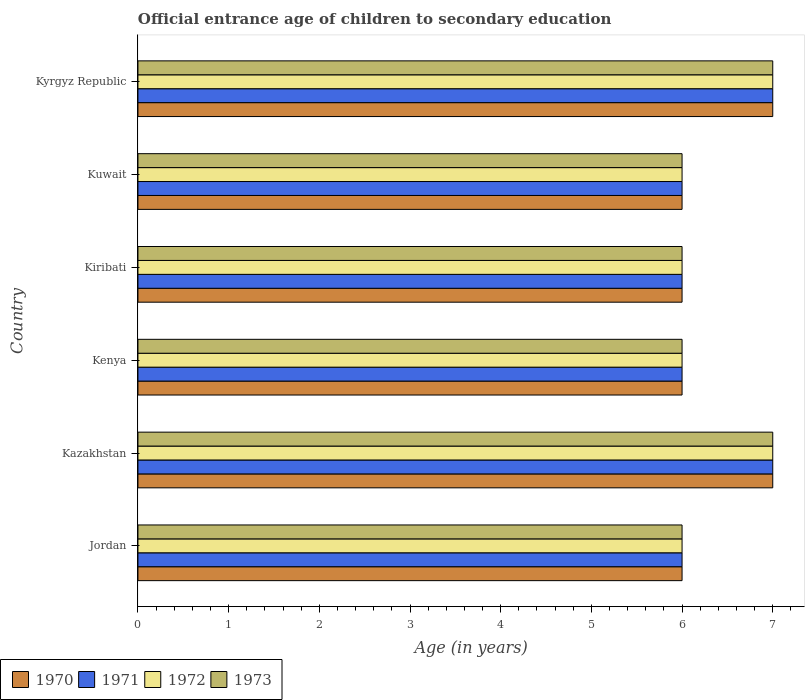How many different coloured bars are there?
Ensure brevity in your answer.  4. How many groups of bars are there?
Make the answer very short. 6. What is the label of the 5th group of bars from the top?
Make the answer very short. Kazakhstan. What is the secondary school starting age of children in 1972 in Kyrgyz Republic?
Keep it short and to the point. 7. Across all countries, what is the maximum secondary school starting age of children in 1970?
Your response must be concise. 7. Across all countries, what is the minimum secondary school starting age of children in 1970?
Provide a succinct answer. 6. In which country was the secondary school starting age of children in 1972 maximum?
Give a very brief answer. Kazakhstan. In which country was the secondary school starting age of children in 1972 minimum?
Keep it short and to the point. Jordan. What is the difference between the secondary school starting age of children in 1971 in Kazakhstan and the secondary school starting age of children in 1973 in Kuwait?
Your response must be concise. 1. What is the average secondary school starting age of children in 1970 per country?
Your response must be concise. 6.33. Is the secondary school starting age of children in 1971 in Kazakhstan less than that in Kuwait?
Offer a terse response. No. What is the difference between the highest and the second highest secondary school starting age of children in 1973?
Offer a very short reply. 0. What is the difference between the highest and the lowest secondary school starting age of children in 1973?
Your answer should be compact. 1. Is the sum of the secondary school starting age of children in 1972 in Kazakhstan and Kyrgyz Republic greater than the maximum secondary school starting age of children in 1970 across all countries?
Give a very brief answer. Yes. What does the 2nd bar from the bottom in Kuwait represents?
Make the answer very short. 1971. How many bars are there?
Provide a succinct answer. 24. What is the difference between two consecutive major ticks on the X-axis?
Your answer should be compact. 1. Are the values on the major ticks of X-axis written in scientific E-notation?
Offer a terse response. No. Does the graph contain any zero values?
Make the answer very short. No. Does the graph contain grids?
Ensure brevity in your answer.  No. Where does the legend appear in the graph?
Ensure brevity in your answer.  Bottom left. How many legend labels are there?
Give a very brief answer. 4. How are the legend labels stacked?
Your response must be concise. Horizontal. What is the title of the graph?
Offer a very short reply. Official entrance age of children to secondary education. What is the label or title of the X-axis?
Your answer should be very brief. Age (in years). What is the Age (in years) of 1972 in Jordan?
Provide a short and direct response. 6. What is the Age (in years) in 1970 in Kazakhstan?
Your response must be concise. 7. What is the Age (in years) in 1972 in Kazakhstan?
Keep it short and to the point. 7. What is the Age (in years) in 1973 in Kazakhstan?
Give a very brief answer. 7. What is the Age (in years) of 1970 in Kenya?
Offer a terse response. 6. What is the Age (in years) of 1973 in Kenya?
Provide a short and direct response. 6. What is the Age (in years) in 1970 in Kiribati?
Ensure brevity in your answer.  6. What is the Age (in years) in 1973 in Kiribati?
Provide a short and direct response. 6. What is the Age (in years) of 1972 in Kuwait?
Your answer should be compact. 6. What is the Age (in years) in 1973 in Kuwait?
Ensure brevity in your answer.  6. What is the Age (in years) of 1973 in Kyrgyz Republic?
Provide a succinct answer. 7. Across all countries, what is the maximum Age (in years) in 1970?
Your answer should be compact. 7. Across all countries, what is the maximum Age (in years) in 1971?
Make the answer very short. 7. Across all countries, what is the minimum Age (in years) in 1970?
Give a very brief answer. 6. Across all countries, what is the minimum Age (in years) of 1971?
Keep it short and to the point. 6. Across all countries, what is the minimum Age (in years) in 1973?
Keep it short and to the point. 6. What is the difference between the Age (in years) in 1972 in Jordan and that in Kazakhstan?
Provide a short and direct response. -1. What is the difference between the Age (in years) in 1973 in Jordan and that in Kazakhstan?
Keep it short and to the point. -1. What is the difference between the Age (in years) in 1970 in Jordan and that in Kenya?
Keep it short and to the point. 0. What is the difference between the Age (in years) in 1972 in Jordan and that in Kenya?
Offer a very short reply. 0. What is the difference between the Age (in years) in 1973 in Jordan and that in Kenya?
Offer a very short reply. 0. What is the difference between the Age (in years) in 1970 in Jordan and that in Kiribati?
Offer a very short reply. 0. What is the difference between the Age (in years) in 1971 in Jordan and that in Kiribati?
Your answer should be very brief. 0. What is the difference between the Age (in years) of 1973 in Jordan and that in Kiribati?
Offer a terse response. 0. What is the difference between the Age (in years) of 1970 in Jordan and that in Kuwait?
Keep it short and to the point. 0. What is the difference between the Age (in years) of 1971 in Jordan and that in Kyrgyz Republic?
Provide a short and direct response. -1. What is the difference between the Age (in years) in 1972 in Jordan and that in Kyrgyz Republic?
Provide a short and direct response. -1. What is the difference between the Age (in years) of 1973 in Jordan and that in Kyrgyz Republic?
Offer a very short reply. -1. What is the difference between the Age (in years) of 1971 in Kazakhstan and that in Kenya?
Ensure brevity in your answer.  1. What is the difference between the Age (in years) of 1972 in Kazakhstan and that in Kenya?
Your response must be concise. 1. What is the difference between the Age (in years) of 1971 in Kazakhstan and that in Kiribati?
Ensure brevity in your answer.  1. What is the difference between the Age (in years) of 1970 in Kazakhstan and that in Kuwait?
Ensure brevity in your answer.  1. What is the difference between the Age (in years) in 1971 in Kazakhstan and that in Kuwait?
Provide a short and direct response. 1. What is the difference between the Age (in years) in 1972 in Kazakhstan and that in Kyrgyz Republic?
Your response must be concise. 0. What is the difference between the Age (in years) in 1973 in Kazakhstan and that in Kyrgyz Republic?
Provide a short and direct response. 0. What is the difference between the Age (in years) of 1970 in Kenya and that in Kiribati?
Make the answer very short. 0. What is the difference between the Age (in years) in 1971 in Kenya and that in Kiribati?
Provide a succinct answer. 0. What is the difference between the Age (in years) of 1973 in Kenya and that in Kyrgyz Republic?
Provide a succinct answer. -1. What is the difference between the Age (in years) in 1970 in Kiribati and that in Kuwait?
Your answer should be compact. 0. What is the difference between the Age (in years) in 1970 in Kiribati and that in Kyrgyz Republic?
Make the answer very short. -1. What is the difference between the Age (in years) of 1971 in Kiribati and that in Kyrgyz Republic?
Make the answer very short. -1. What is the difference between the Age (in years) of 1972 in Kiribati and that in Kyrgyz Republic?
Offer a very short reply. -1. What is the difference between the Age (in years) in 1970 in Kuwait and that in Kyrgyz Republic?
Keep it short and to the point. -1. What is the difference between the Age (in years) of 1971 in Kuwait and that in Kyrgyz Republic?
Ensure brevity in your answer.  -1. What is the difference between the Age (in years) in 1970 in Jordan and the Age (in years) in 1972 in Kazakhstan?
Your answer should be very brief. -1. What is the difference between the Age (in years) in 1971 in Jordan and the Age (in years) in 1973 in Kazakhstan?
Offer a very short reply. -1. What is the difference between the Age (in years) of 1970 in Jordan and the Age (in years) of 1973 in Kenya?
Ensure brevity in your answer.  0. What is the difference between the Age (in years) in 1971 in Jordan and the Age (in years) in 1972 in Kiribati?
Give a very brief answer. 0. What is the difference between the Age (in years) in 1971 in Jordan and the Age (in years) in 1973 in Kiribati?
Offer a very short reply. 0. What is the difference between the Age (in years) of 1972 in Jordan and the Age (in years) of 1973 in Kiribati?
Keep it short and to the point. 0. What is the difference between the Age (in years) of 1970 in Jordan and the Age (in years) of 1971 in Kuwait?
Make the answer very short. 0. What is the difference between the Age (in years) of 1970 in Jordan and the Age (in years) of 1973 in Kuwait?
Your answer should be very brief. 0. What is the difference between the Age (in years) of 1971 in Jordan and the Age (in years) of 1972 in Kuwait?
Give a very brief answer. 0. What is the difference between the Age (in years) in 1970 in Jordan and the Age (in years) in 1972 in Kyrgyz Republic?
Keep it short and to the point. -1. What is the difference between the Age (in years) of 1971 in Jordan and the Age (in years) of 1972 in Kyrgyz Republic?
Your response must be concise. -1. What is the difference between the Age (in years) in 1971 in Jordan and the Age (in years) in 1973 in Kyrgyz Republic?
Your answer should be compact. -1. What is the difference between the Age (in years) in 1970 in Kazakhstan and the Age (in years) in 1971 in Kenya?
Offer a very short reply. 1. What is the difference between the Age (in years) in 1970 in Kazakhstan and the Age (in years) in 1972 in Kenya?
Offer a terse response. 1. What is the difference between the Age (in years) in 1971 in Kazakhstan and the Age (in years) in 1972 in Kenya?
Ensure brevity in your answer.  1. What is the difference between the Age (in years) of 1972 in Kazakhstan and the Age (in years) of 1973 in Kenya?
Offer a terse response. 1. What is the difference between the Age (in years) of 1970 in Kazakhstan and the Age (in years) of 1973 in Kiribati?
Your answer should be compact. 1. What is the difference between the Age (in years) in 1971 in Kazakhstan and the Age (in years) in 1973 in Kiribati?
Your answer should be very brief. 1. What is the difference between the Age (in years) of 1972 in Kazakhstan and the Age (in years) of 1973 in Kiribati?
Your answer should be very brief. 1. What is the difference between the Age (in years) of 1971 in Kazakhstan and the Age (in years) of 1972 in Kuwait?
Provide a short and direct response. 1. What is the difference between the Age (in years) of 1971 in Kazakhstan and the Age (in years) of 1973 in Kuwait?
Your response must be concise. 1. What is the difference between the Age (in years) of 1970 in Kazakhstan and the Age (in years) of 1972 in Kyrgyz Republic?
Make the answer very short. 0. What is the difference between the Age (in years) in 1970 in Kazakhstan and the Age (in years) in 1973 in Kyrgyz Republic?
Provide a succinct answer. 0. What is the difference between the Age (in years) of 1971 in Kazakhstan and the Age (in years) of 1973 in Kyrgyz Republic?
Ensure brevity in your answer.  0. What is the difference between the Age (in years) in 1970 in Kenya and the Age (in years) in 1971 in Kiribati?
Your response must be concise. 0. What is the difference between the Age (in years) in 1970 in Kenya and the Age (in years) in 1973 in Kiribati?
Your answer should be very brief. 0. What is the difference between the Age (in years) in 1972 in Kenya and the Age (in years) in 1973 in Kiribati?
Provide a succinct answer. 0. What is the difference between the Age (in years) of 1970 in Kenya and the Age (in years) of 1971 in Kuwait?
Provide a succinct answer. 0. What is the difference between the Age (in years) in 1970 in Kenya and the Age (in years) in 1973 in Kuwait?
Ensure brevity in your answer.  0. What is the difference between the Age (in years) of 1971 in Kenya and the Age (in years) of 1973 in Kuwait?
Provide a succinct answer. 0. What is the difference between the Age (in years) in 1970 in Kenya and the Age (in years) in 1972 in Kyrgyz Republic?
Offer a very short reply. -1. What is the difference between the Age (in years) in 1970 in Kenya and the Age (in years) in 1973 in Kyrgyz Republic?
Your answer should be very brief. -1. What is the difference between the Age (in years) in 1971 in Kenya and the Age (in years) in 1972 in Kyrgyz Republic?
Offer a terse response. -1. What is the difference between the Age (in years) in 1972 in Kenya and the Age (in years) in 1973 in Kyrgyz Republic?
Your answer should be very brief. -1. What is the difference between the Age (in years) in 1970 in Kiribati and the Age (in years) in 1971 in Kuwait?
Offer a terse response. 0. What is the difference between the Age (in years) of 1970 in Kiribati and the Age (in years) of 1972 in Kuwait?
Offer a terse response. 0. What is the difference between the Age (in years) in 1970 in Kiribati and the Age (in years) in 1973 in Kuwait?
Offer a very short reply. 0. What is the difference between the Age (in years) of 1971 in Kiribati and the Age (in years) of 1972 in Kuwait?
Provide a short and direct response. 0. What is the difference between the Age (in years) in 1971 in Kiribati and the Age (in years) in 1973 in Kuwait?
Provide a short and direct response. 0. What is the difference between the Age (in years) of 1970 in Kiribati and the Age (in years) of 1971 in Kyrgyz Republic?
Provide a short and direct response. -1. What is the difference between the Age (in years) of 1971 in Kiribati and the Age (in years) of 1972 in Kyrgyz Republic?
Provide a succinct answer. -1. What is the difference between the Age (in years) of 1971 in Kiribati and the Age (in years) of 1973 in Kyrgyz Republic?
Offer a terse response. -1. What is the difference between the Age (in years) in 1970 in Kuwait and the Age (in years) in 1971 in Kyrgyz Republic?
Provide a succinct answer. -1. What is the difference between the Age (in years) in 1970 in Kuwait and the Age (in years) in 1972 in Kyrgyz Republic?
Your response must be concise. -1. What is the difference between the Age (in years) of 1970 in Kuwait and the Age (in years) of 1973 in Kyrgyz Republic?
Your answer should be very brief. -1. What is the average Age (in years) of 1970 per country?
Provide a short and direct response. 6.33. What is the average Age (in years) of 1971 per country?
Keep it short and to the point. 6.33. What is the average Age (in years) of 1972 per country?
Offer a very short reply. 6.33. What is the average Age (in years) in 1973 per country?
Ensure brevity in your answer.  6.33. What is the difference between the Age (in years) in 1970 and Age (in years) in 1971 in Jordan?
Your response must be concise. 0. What is the difference between the Age (in years) of 1970 and Age (in years) of 1972 in Jordan?
Offer a terse response. 0. What is the difference between the Age (in years) in 1971 and Age (in years) in 1972 in Jordan?
Provide a short and direct response. 0. What is the difference between the Age (in years) of 1971 and Age (in years) of 1973 in Jordan?
Ensure brevity in your answer.  0. What is the difference between the Age (in years) in 1972 and Age (in years) in 1973 in Jordan?
Ensure brevity in your answer.  0. What is the difference between the Age (in years) of 1970 and Age (in years) of 1971 in Kazakhstan?
Provide a short and direct response. 0. What is the difference between the Age (in years) of 1971 and Age (in years) of 1972 in Kenya?
Keep it short and to the point. 0. What is the difference between the Age (in years) of 1972 and Age (in years) of 1973 in Kenya?
Provide a succinct answer. 0. What is the difference between the Age (in years) in 1970 and Age (in years) in 1972 in Kiribati?
Provide a short and direct response. 0. What is the difference between the Age (in years) of 1971 and Age (in years) of 1973 in Kiribati?
Provide a succinct answer. 0. What is the difference between the Age (in years) of 1970 and Age (in years) of 1972 in Kuwait?
Offer a terse response. 0. What is the difference between the Age (in years) of 1970 and Age (in years) of 1973 in Kuwait?
Make the answer very short. 0. What is the difference between the Age (in years) in 1971 and Age (in years) in 1973 in Kuwait?
Provide a succinct answer. 0. What is the difference between the Age (in years) of 1970 and Age (in years) of 1972 in Kyrgyz Republic?
Offer a terse response. 0. What is the ratio of the Age (in years) of 1970 in Jordan to that in Kazakhstan?
Offer a terse response. 0.86. What is the ratio of the Age (in years) in 1971 in Jordan to that in Kazakhstan?
Offer a terse response. 0.86. What is the ratio of the Age (in years) in 1970 in Jordan to that in Kenya?
Your answer should be very brief. 1. What is the ratio of the Age (in years) in 1971 in Jordan to that in Kenya?
Provide a succinct answer. 1. What is the ratio of the Age (in years) of 1972 in Jordan to that in Kenya?
Provide a short and direct response. 1. What is the ratio of the Age (in years) in 1970 in Jordan to that in Kiribati?
Make the answer very short. 1. What is the ratio of the Age (in years) of 1971 in Jordan to that in Kiribati?
Offer a terse response. 1. What is the ratio of the Age (in years) in 1972 in Jordan to that in Kiribati?
Ensure brevity in your answer.  1. What is the ratio of the Age (in years) in 1970 in Jordan to that in Kuwait?
Your answer should be compact. 1. What is the ratio of the Age (in years) in 1972 in Jordan to that in Kuwait?
Offer a terse response. 1. What is the ratio of the Age (in years) of 1973 in Jordan to that in Kuwait?
Give a very brief answer. 1. What is the ratio of the Age (in years) of 1971 in Jordan to that in Kyrgyz Republic?
Make the answer very short. 0.86. What is the ratio of the Age (in years) of 1972 in Jordan to that in Kyrgyz Republic?
Provide a succinct answer. 0.86. What is the ratio of the Age (in years) of 1971 in Kazakhstan to that in Kenya?
Keep it short and to the point. 1.17. What is the ratio of the Age (in years) of 1972 in Kazakhstan to that in Kenya?
Make the answer very short. 1.17. What is the ratio of the Age (in years) of 1973 in Kazakhstan to that in Kenya?
Offer a terse response. 1.17. What is the ratio of the Age (in years) in 1971 in Kazakhstan to that in Kiribati?
Your answer should be very brief. 1.17. What is the ratio of the Age (in years) in 1973 in Kazakhstan to that in Kiribati?
Your answer should be compact. 1.17. What is the ratio of the Age (in years) of 1970 in Kazakhstan to that in Kuwait?
Offer a very short reply. 1.17. What is the ratio of the Age (in years) in 1971 in Kazakhstan to that in Kuwait?
Ensure brevity in your answer.  1.17. What is the ratio of the Age (in years) of 1972 in Kazakhstan to that in Kuwait?
Give a very brief answer. 1.17. What is the ratio of the Age (in years) in 1973 in Kazakhstan to that in Kuwait?
Provide a succinct answer. 1.17. What is the ratio of the Age (in years) of 1970 in Kazakhstan to that in Kyrgyz Republic?
Ensure brevity in your answer.  1. What is the ratio of the Age (in years) in 1971 in Kazakhstan to that in Kyrgyz Republic?
Make the answer very short. 1. What is the ratio of the Age (in years) of 1972 in Kazakhstan to that in Kyrgyz Republic?
Provide a short and direct response. 1. What is the ratio of the Age (in years) in 1973 in Kazakhstan to that in Kyrgyz Republic?
Keep it short and to the point. 1. What is the ratio of the Age (in years) in 1973 in Kenya to that in Kiribati?
Offer a terse response. 1. What is the ratio of the Age (in years) in 1970 in Kenya to that in Kuwait?
Ensure brevity in your answer.  1. What is the ratio of the Age (in years) of 1971 in Kenya to that in Kuwait?
Your answer should be compact. 1. What is the ratio of the Age (in years) in 1971 in Kenya to that in Kyrgyz Republic?
Ensure brevity in your answer.  0.86. What is the ratio of the Age (in years) in 1973 in Kenya to that in Kyrgyz Republic?
Keep it short and to the point. 0.86. What is the ratio of the Age (in years) of 1971 in Kiribati to that in Kyrgyz Republic?
Your answer should be very brief. 0.86. What is the ratio of the Age (in years) in 1972 in Kiribati to that in Kyrgyz Republic?
Give a very brief answer. 0.86. What is the ratio of the Age (in years) in 1970 in Kuwait to that in Kyrgyz Republic?
Your response must be concise. 0.86. What is the ratio of the Age (in years) in 1971 in Kuwait to that in Kyrgyz Republic?
Provide a short and direct response. 0.86. What is the ratio of the Age (in years) in 1972 in Kuwait to that in Kyrgyz Republic?
Your response must be concise. 0.86. What is the difference between the highest and the second highest Age (in years) of 1970?
Provide a succinct answer. 0. What is the difference between the highest and the second highest Age (in years) of 1971?
Provide a succinct answer. 0. What is the difference between the highest and the second highest Age (in years) in 1972?
Provide a succinct answer. 0. What is the difference between the highest and the second highest Age (in years) of 1973?
Make the answer very short. 0. What is the difference between the highest and the lowest Age (in years) in 1970?
Make the answer very short. 1. What is the difference between the highest and the lowest Age (in years) of 1971?
Give a very brief answer. 1. What is the difference between the highest and the lowest Age (in years) in 1972?
Your answer should be very brief. 1. 